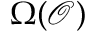<formula> <loc_0><loc_0><loc_500><loc_500>\Omega ( { \mathcal { O } } )</formula> 